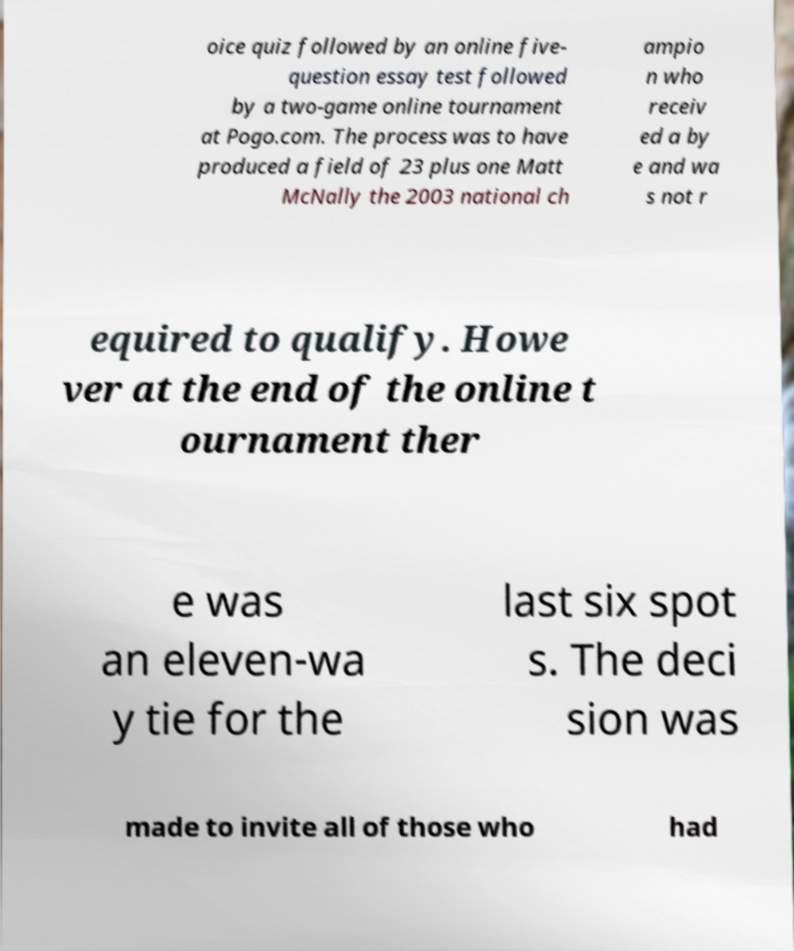I need the written content from this picture converted into text. Can you do that? oice quiz followed by an online five- question essay test followed by a two-game online tournament at Pogo.com. The process was to have produced a field of 23 plus one Matt McNally the 2003 national ch ampio n who receiv ed a by e and wa s not r equired to qualify. Howe ver at the end of the online t ournament ther e was an eleven-wa y tie for the last six spot s. The deci sion was made to invite all of those who had 